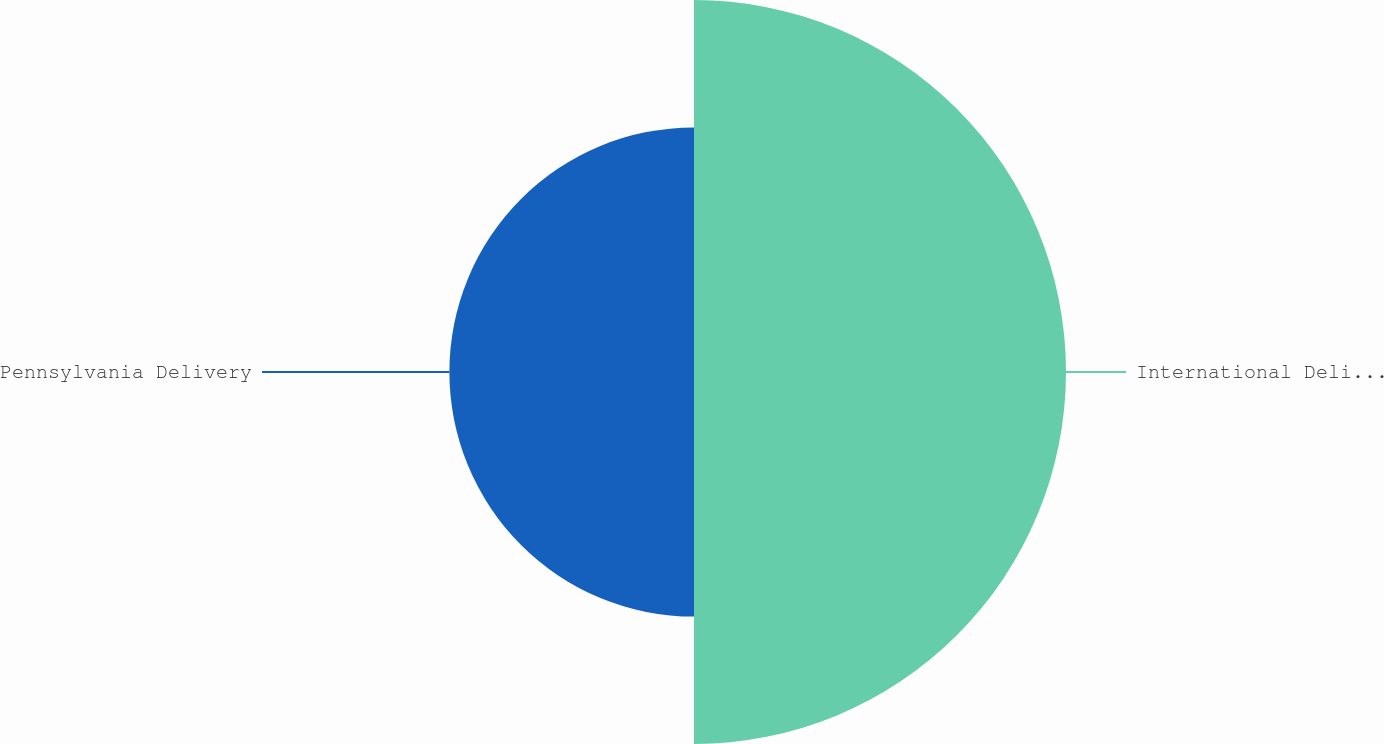Convert chart to OTSL. <chart><loc_0><loc_0><loc_500><loc_500><pie_chart><fcel>International Delivery<fcel>Pennsylvania Delivery<nl><fcel>60.33%<fcel>39.67%<nl></chart> 